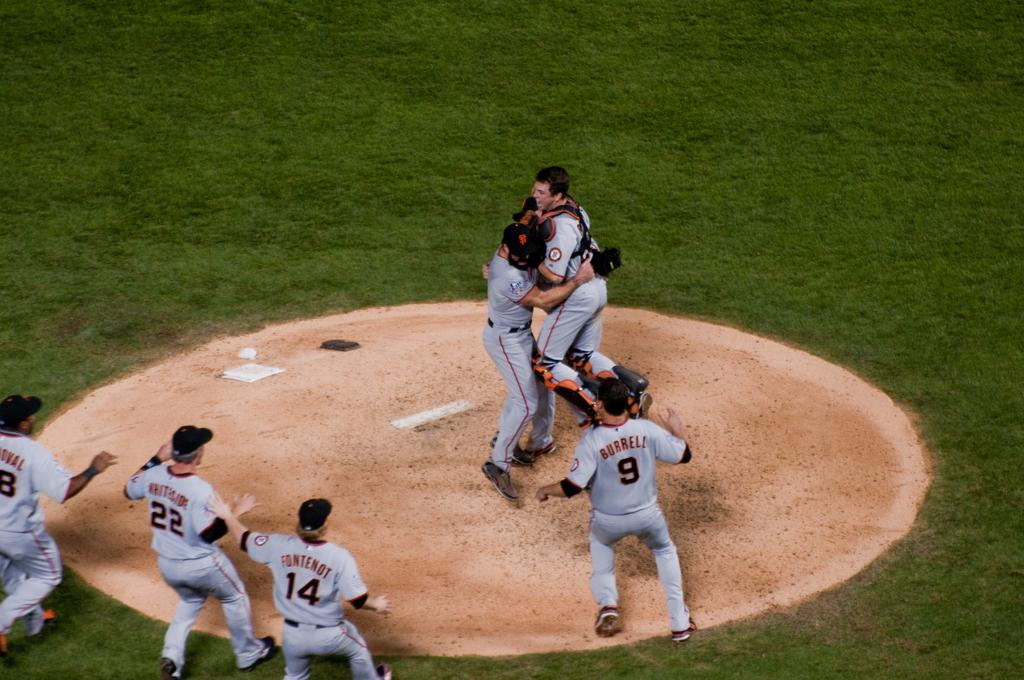Provide a one-sentence caption for the provided image. San Francisco Giants team hugging each other and celebrating for winning a baseball game. 